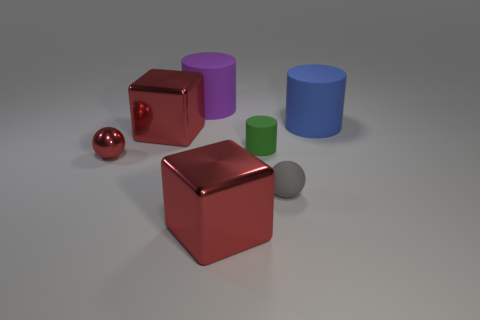The blue object that is the same size as the purple rubber cylinder is what shape?
Ensure brevity in your answer.  Cylinder. What number of things are either big objects to the left of the gray ball or big red objects that are behind the small green rubber object?
Your response must be concise. 3. What is the material of the green thing that is the same size as the gray sphere?
Offer a very short reply. Rubber. How many other things are the same material as the small gray object?
Offer a terse response. 3. Are there the same number of large metal things that are behind the tiny gray rubber ball and gray rubber balls on the left side of the metallic sphere?
Ensure brevity in your answer.  No. What number of red objects are big cubes or rubber cylinders?
Ensure brevity in your answer.  2. There is a small metal ball; is its color the same as the big cylinder to the right of the green object?
Offer a very short reply. No. What number of other things are the same color as the metallic sphere?
Your answer should be compact. 2. Is the number of small cylinders less than the number of big red shiny blocks?
Provide a short and direct response. Yes. There is a red metal cube behind the large red block that is on the right side of the large purple matte object; what number of tiny objects are left of it?
Offer a very short reply. 1. 